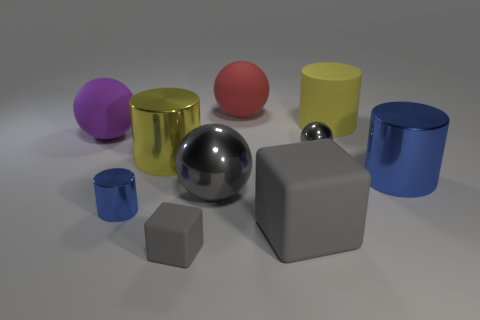What materials do the objects in the image appear to be made of? The objects in the image appear to have a variety of materials. The spheres and cylinders present finishes that resemble matte paint, shiny metal, and a smooth plastic or rubber-like material. The surfaces are rendered with different degrees of reflectivity suggesting various textures. 